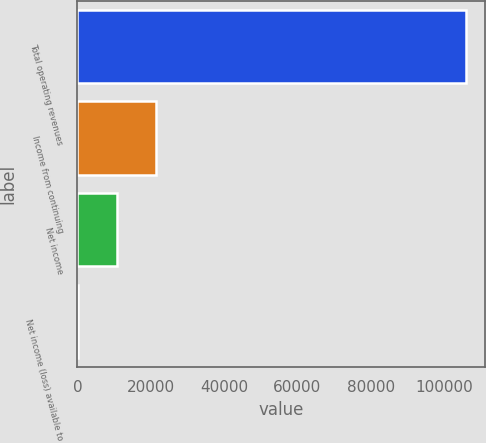<chart> <loc_0><loc_0><loc_500><loc_500><bar_chart><fcel>Total operating revenues<fcel>Income from continuing<fcel>Net income<fcel>Net income (loss) available to<nl><fcel>105903<fcel>21383.8<fcel>10818.9<fcel>254<nl></chart> 